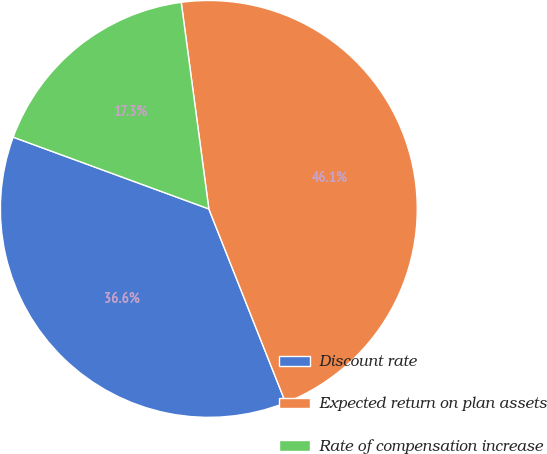Convert chart to OTSL. <chart><loc_0><loc_0><loc_500><loc_500><pie_chart><fcel>Discount rate<fcel>Expected return on plan assets<fcel>Rate of compensation increase<nl><fcel>36.6%<fcel>46.11%<fcel>17.29%<nl></chart> 